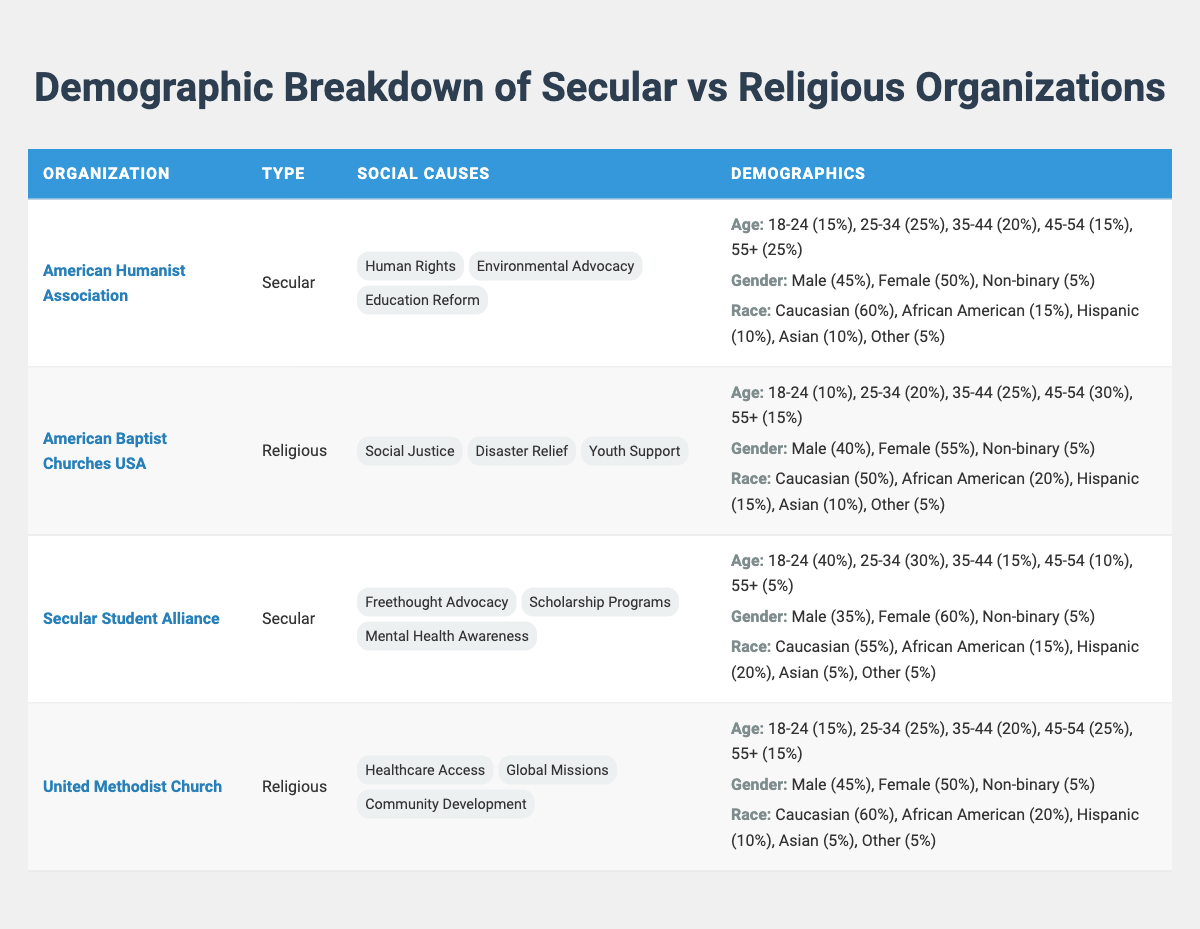What is the organization name of the secular group that focuses on Human Rights? According to the table, the organization name that belongs to the secular group and focuses on Human Rights is the American Humanist Association.
Answer: American Humanist Association Which organization has a higher percentage of male participants, the American Baptist Churches USA or the American Humanist Association? The American Baptist Churches USA has 40% male participants, while the American Humanist Association has 45%. Therefore, the American Humanist Association has a higher percentage of male participants.
Answer: American Humanist Association What is the total percentage of participants aged 35-44 across all organizations listed in the table? For the American Humanist Association, the percentage for ages 35-44 is 20%. For American Baptist Churches USA, it's 25%. For Secular Student Alliance, it's 15%. For United Methodist Church, it's 20%. Adding these percentages gives 20% + 25% + 15% + 20% = 80%.
Answer: 80% Do any of the secular organizations have a higher percentage of 18-24-year-old participants than the religious organizations? Yes, the Secular Student Alliance has 40% of participants who are aged 18-24, which is higher than both religious organizations (American Baptist Churches USA has 10% and United Methodist Church has 15%).
Answer: Yes Which demographic characteristic was most prevalent among participants of the Secular Student Alliance? In the Secular Student Alliance, Female participants were the most prevalent demographic characteristic with a percentage of 60%.
Answer: Female What is the combined percentage of Hispanic and African American participants in religious organizations? For the American Baptist Churches USA, Hispanic participants make up 15% and African American participants make up 20%, giving a combined percentage of 15% + 20% = 35%. For the United Methodist Church, they represent 10% and 20%, respectively, adding up to 30%. Adding both organizations together gives 35% + 30% = 65%.
Answer: 65% Which organization has the lowest representation of participants aged 55 and older? The Secular Student Alliance has the lowest representation of participants aged 55 and older at 5%. The other organizations have 15% or more in that age category.
Answer: Secular Student Alliance Do the organizations focusing on social justice causes have a higher percentage of female participants compared to those focusing on human rights? Yes, the American Baptist Churches USA has 55% female participants, while the American Humanist Association has 50%. Thus, organizations focusing on social justice have a higher percentage of female participants.
Answer: Yes 